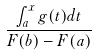Convert formula to latex. <formula><loc_0><loc_0><loc_500><loc_500>\frac { \int _ { a } ^ { x } g ( t ) d t } { F ( b ) - F ( a ) }</formula> 